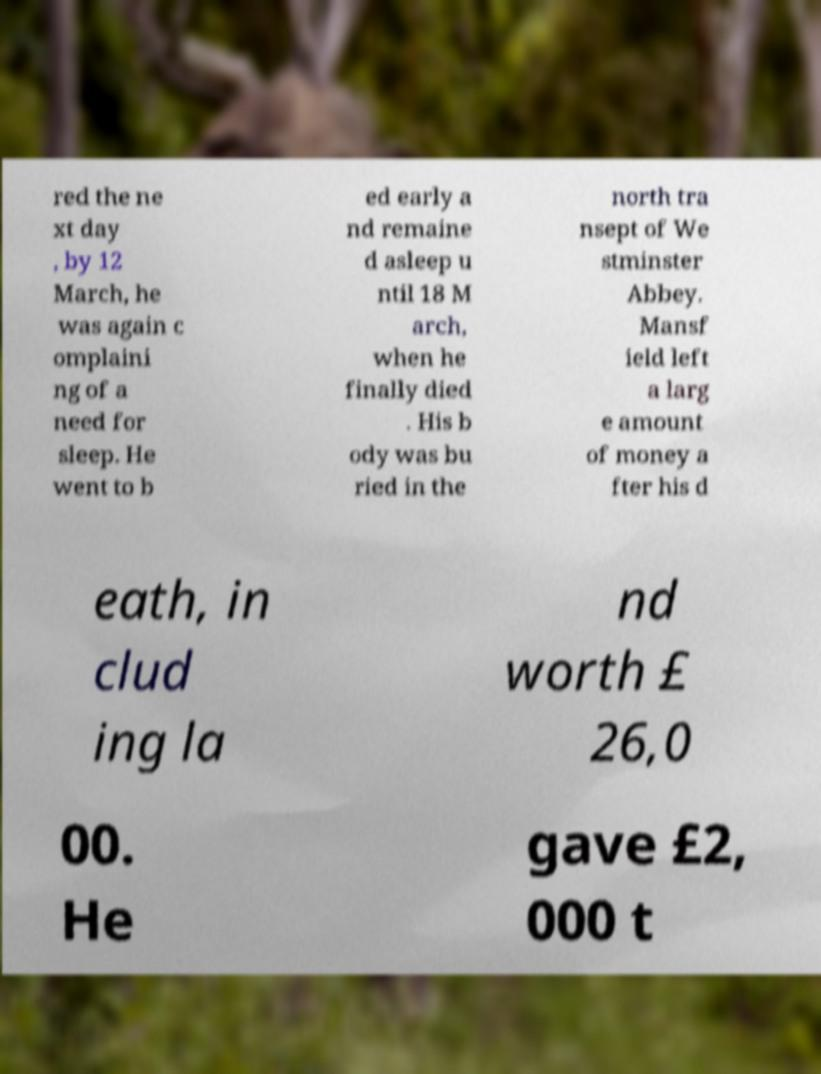Please read and relay the text visible in this image. What does it say? red the ne xt day , by 12 March, he was again c omplaini ng of a need for sleep. He went to b ed early a nd remaine d asleep u ntil 18 M arch, when he finally died . His b ody was bu ried in the north tra nsept of We stminster Abbey. Mansf ield left a larg e amount of money a fter his d eath, in clud ing la nd worth £ 26,0 00. He gave £2, 000 t 